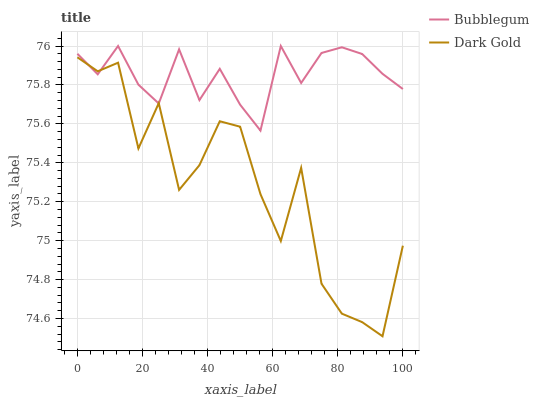Does Dark Gold have the minimum area under the curve?
Answer yes or no. Yes. Does Bubblegum have the maximum area under the curve?
Answer yes or no. Yes. Does Dark Gold have the maximum area under the curve?
Answer yes or no. No. Is Bubblegum the smoothest?
Answer yes or no. Yes. Is Dark Gold the roughest?
Answer yes or no. Yes. Is Dark Gold the smoothest?
Answer yes or no. No. Does Dark Gold have the lowest value?
Answer yes or no. Yes. Does Bubblegum have the highest value?
Answer yes or no. Yes. Does Dark Gold have the highest value?
Answer yes or no. No. Does Bubblegum intersect Dark Gold?
Answer yes or no. Yes. Is Bubblegum less than Dark Gold?
Answer yes or no. No. Is Bubblegum greater than Dark Gold?
Answer yes or no. No. 